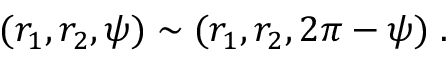<formula> <loc_0><loc_0><loc_500><loc_500>( r _ { 1 } , r _ { 2 } , \psi ) \sim ( r _ { 1 } , r _ { 2 } , 2 \pi - \psi ) \, .</formula> 